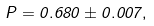<formula> <loc_0><loc_0><loc_500><loc_500>P = 0 . 6 8 0 \pm 0 . 0 0 7 ,</formula> 